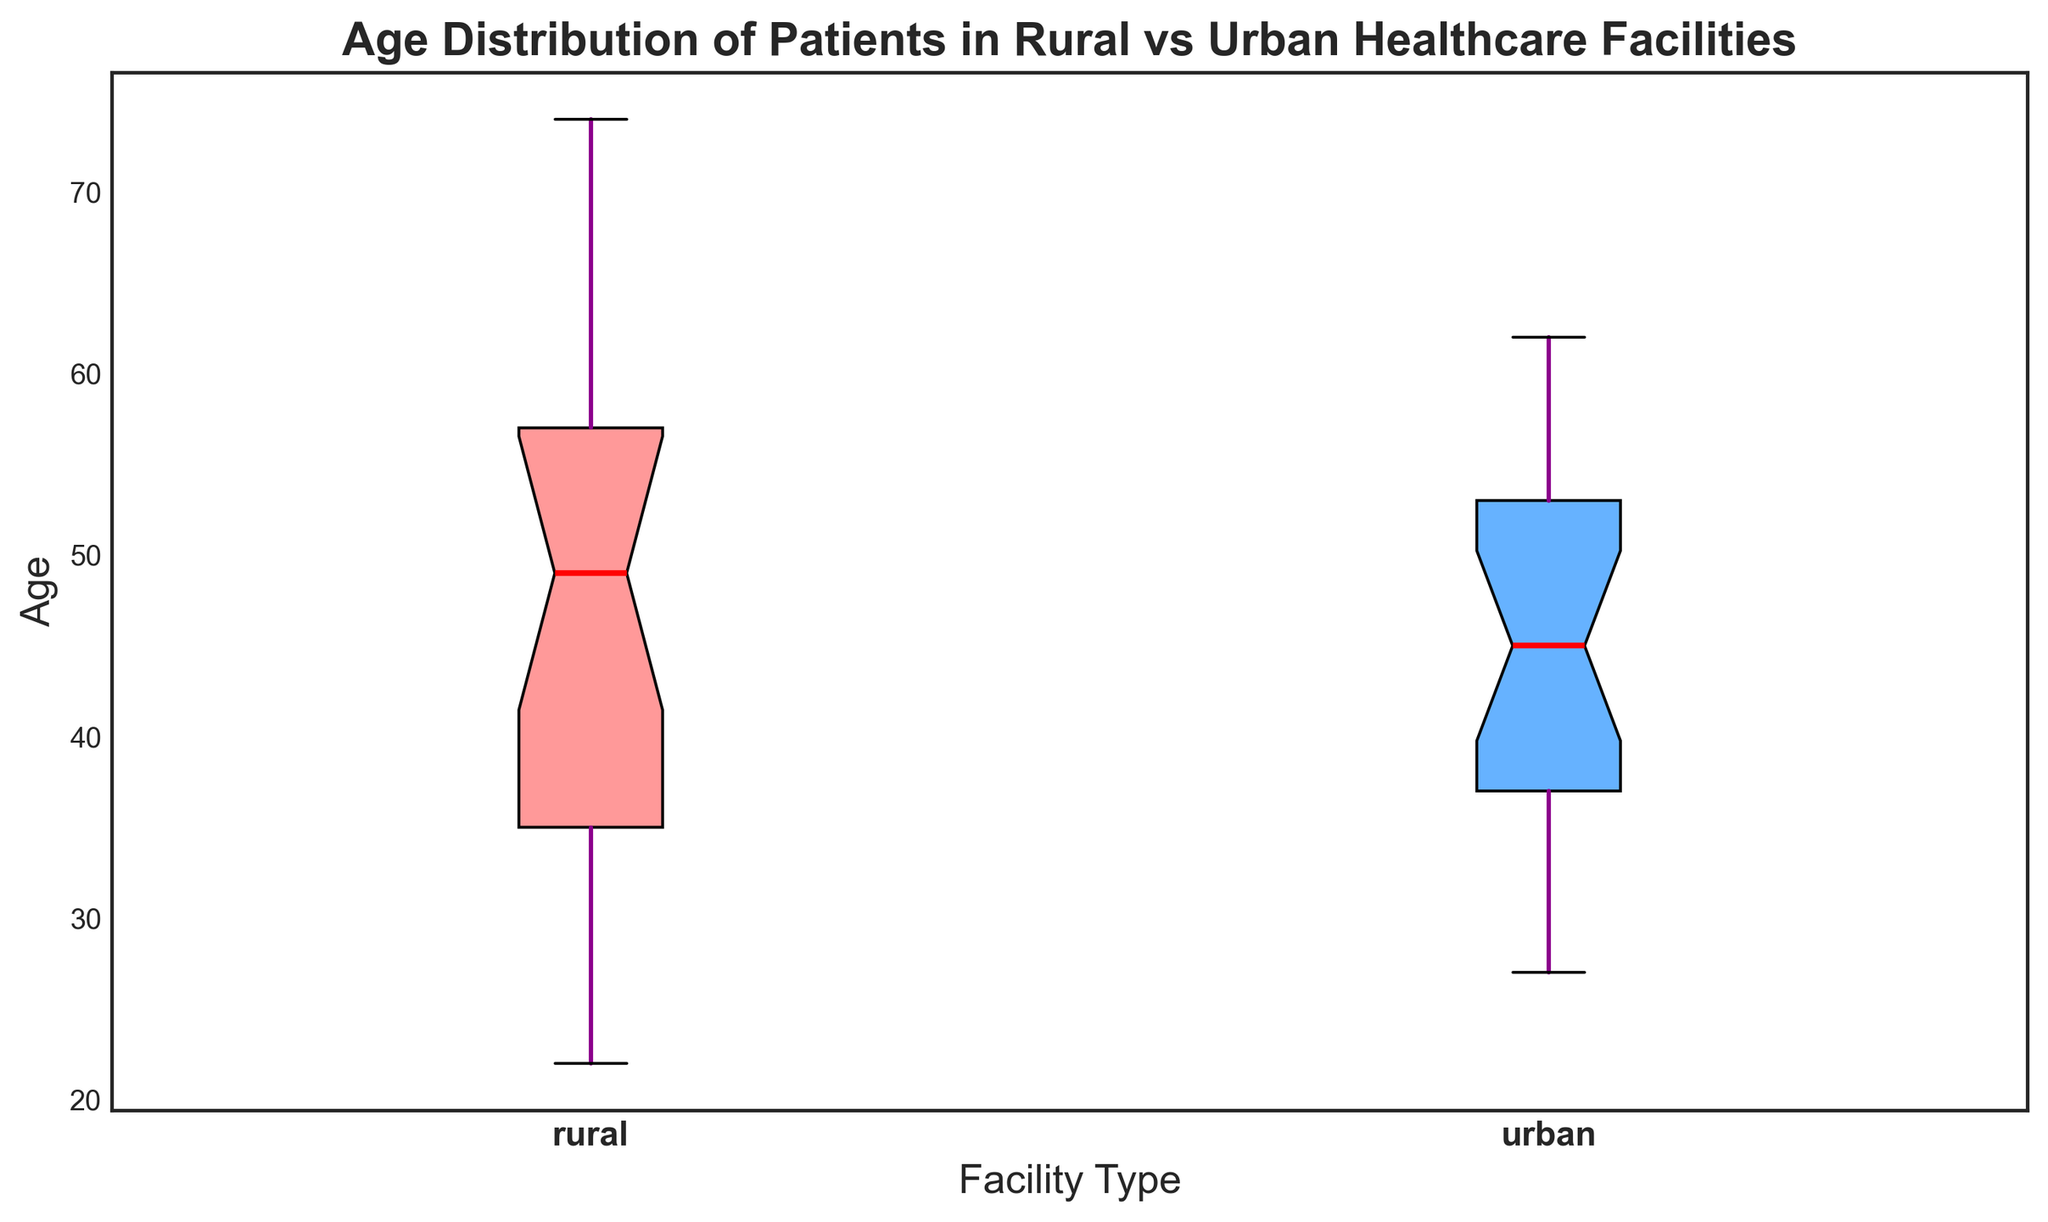Which facility type has a higher median age of patients? Look at the red lines inside the boxes to locate the median ages for each facility type. The box for the rural facility has its median line higher compared to the urban facility.
Answer: Rural What is the interquartile range (IQR) for the age distribution in rural healthcare facilities? First, identify the quartiles: the top and bottom edges of the box represent the third (Q3) and first (Q1) quartiles, respectively. Calculate the IQR as Q3 minus Q1. The rural box shows Q3 at around 63 and Q1 at 33. IQR = 63 - 33 = 30.
Answer: 30 Which group has a larger spread in the ages of patients? Observing the length of the boxes and the whiskers, the rural facilities' box and whiskers extend over a wider range of ages compared to the urban facilities, indicating a larger spread.
Answer: Rural What is the range of patient ages in urban healthcare facilities? The range is calculated by subtracting the minimum value (bottom whisker) from the maximum value (top whisker) in the urban box plot. From the visual, the approximate maximum is 62, and the minimum is 27. Range = 62 - 27 = 35.
Answer: 35 Are there any outliers in the age distribution of either facility type? Outliers are visually represented by points outside of the whiskers. In both box plots, there are no points that are distinctly separate from the whiskers, indicating no visible outliers.
Answer: No Which facility type has a younger minimum patient age? Compare the bottom whiskers of both box plots. The bottom whisker for the rural facilities appears lower than that of the urban facilities, indicating a younger minimum age.
Answer: Rural How does the skewness of the age distributions for rural and urban facilities compare? The rural box plot shows a longer upper whisker compared to the lower one, suggesting a right skew. The urban box plot has more balanced whiskers but could also show a slight right skew. Compare the lengths of whiskers and box positions.
Answer: Rural is more skewed What is the approximate median age of patients in urban healthcare facilities? Locate the red median line inside the urban facilities' box plot. It visually aligns with an age value around 45.
Answer: 45 Do rural or urban facilities have a greater variability in patient ages? Variability is indicated by the interquartile range (IQR) and the overall spread of the whiskers. The rural facilities exhibit a larger overall spread and IQR, indicating greater variability.
Answer: Rural 